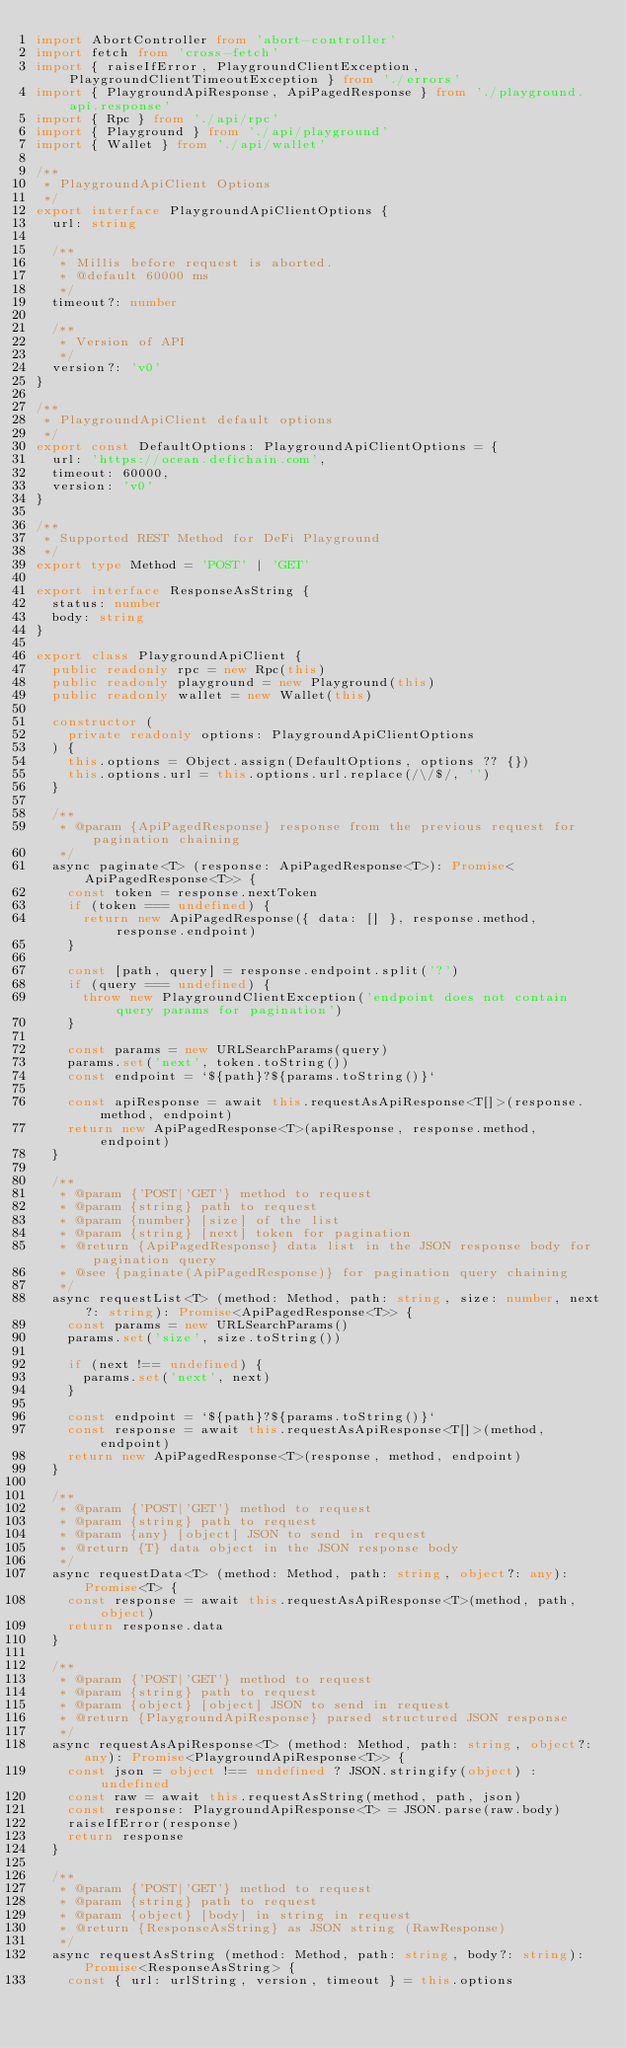<code> <loc_0><loc_0><loc_500><loc_500><_TypeScript_>import AbortController from 'abort-controller'
import fetch from 'cross-fetch'
import { raiseIfError, PlaygroundClientException, PlaygroundClientTimeoutException } from './errors'
import { PlaygroundApiResponse, ApiPagedResponse } from './playground.api.response'
import { Rpc } from './api/rpc'
import { Playground } from './api/playground'
import { Wallet } from './api/wallet'

/**
 * PlaygroundApiClient Options
 */
export interface PlaygroundApiClientOptions {
  url: string

  /**
   * Millis before request is aborted.
   * @default 60000 ms
   */
  timeout?: number

  /**
   * Version of API
   */
  version?: 'v0'
}

/**
 * PlaygroundApiClient default options
 */
export const DefaultOptions: PlaygroundApiClientOptions = {
  url: 'https://ocean.defichain.com',
  timeout: 60000,
  version: 'v0'
}

/**
 * Supported REST Method for DeFi Playground
 */
export type Method = 'POST' | 'GET'

export interface ResponseAsString {
  status: number
  body: string
}

export class PlaygroundApiClient {
  public readonly rpc = new Rpc(this)
  public readonly playground = new Playground(this)
  public readonly wallet = new Wallet(this)

  constructor (
    private readonly options: PlaygroundApiClientOptions
  ) {
    this.options = Object.assign(DefaultOptions, options ?? {})
    this.options.url = this.options.url.replace(/\/$/, '')
  }

  /**
   * @param {ApiPagedResponse} response from the previous request for pagination chaining
   */
  async paginate<T> (response: ApiPagedResponse<T>): Promise<ApiPagedResponse<T>> {
    const token = response.nextToken
    if (token === undefined) {
      return new ApiPagedResponse({ data: [] }, response.method, response.endpoint)
    }

    const [path, query] = response.endpoint.split('?')
    if (query === undefined) {
      throw new PlaygroundClientException('endpoint does not contain query params for pagination')
    }

    const params = new URLSearchParams(query)
    params.set('next', token.toString())
    const endpoint = `${path}?${params.toString()}`

    const apiResponse = await this.requestAsApiResponse<T[]>(response.method, endpoint)
    return new ApiPagedResponse<T>(apiResponse, response.method, endpoint)
  }

  /**
   * @param {'POST|'GET'} method to request
   * @param {string} path to request
   * @param {number} [size] of the list
   * @param {string} [next] token for pagination
   * @return {ApiPagedResponse} data list in the JSON response body for pagination query
   * @see {paginate(ApiPagedResponse)} for pagination query chaining
   */
  async requestList<T> (method: Method, path: string, size: number, next?: string): Promise<ApiPagedResponse<T>> {
    const params = new URLSearchParams()
    params.set('size', size.toString())

    if (next !== undefined) {
      params.set('next', next)
    }

    const endpoint = `${path}?${params.toString()}`
    const response = await this.requestAsApiResponse<T[]>(method, endpoint)
    return new ApiPagedResponse<T>(response, method, endpoint)
  }

  /**
   * @param {'POST|'GET'} method to request
   * @param {string} path to request
   * @param {any} [object] JSON to send in request
   * @return {T} data object in the JSON response body
   */
  async requestData<T> (method: Method, path: string, object?: any): Promise<T> {
    const response = await this.requestAsApiResponse<T>(method, path, object)
    return response.data
  }

  /**
   * @param {'POST|'GET'} method to request
   * @param {string} path to request
   * @param {object} [object] JSON to send in request
   * @return {PlaygroundApiResponse} parsed structured JSON response
   */
  async requestAsApiResponse<T> (method: Method, path: string, object?: any): Promise<PlaygroundApiResponse<T>> {
    const json = object !== undefined ? JSON.stringify(object) : undefined
    const raw = await this.requestAsString(method, path, json)
    const response: PlaygroundApiResponse<T> = JSON.parse(raw.body)
    raiseIfError(response)
    return response
  }

  /**
   * @param {'POST|'GET'} method to request
   * @param {string} path to request
   * @param {object} [body] in string in request
   * @return {ResponseAsString} as JSON string (RawResponse)
   */
  async requestAsString (method: Method, path: string, body?: string): Promise<ResponseAsString> {
    const { url: urlString, version, timeout } = this.options</code> 